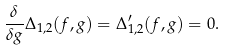Convert formula to latex. <formula><loc_0><loc_0><loc_500><loc_500>\frac { \delta } { \delta g } \Delta _ { 1 , 2 } ( f , g ) = \Delta _ { 1 , 2 } ^ { \prime } ( f , g ) = 0 .</formula> 